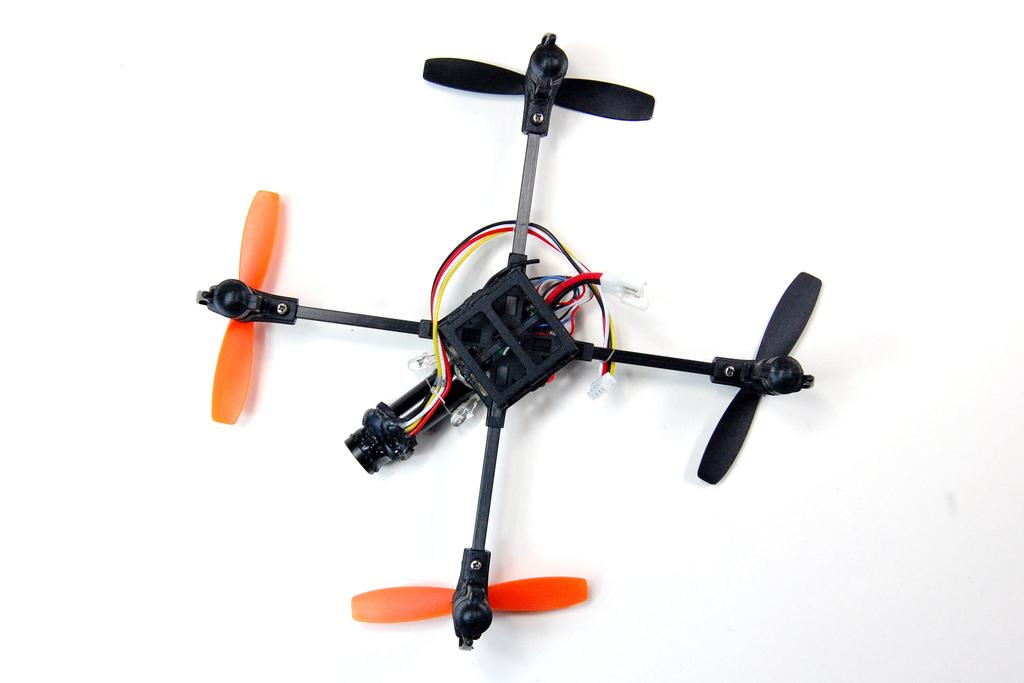What is on the floor in the image? There is a toy on the floor in the image. Can you describe the setting of the image? The image may have been taken in a room. How many men are present in the image? There is no information about men in the image, as it only mentions a toy on the floor and a possible room setting. 